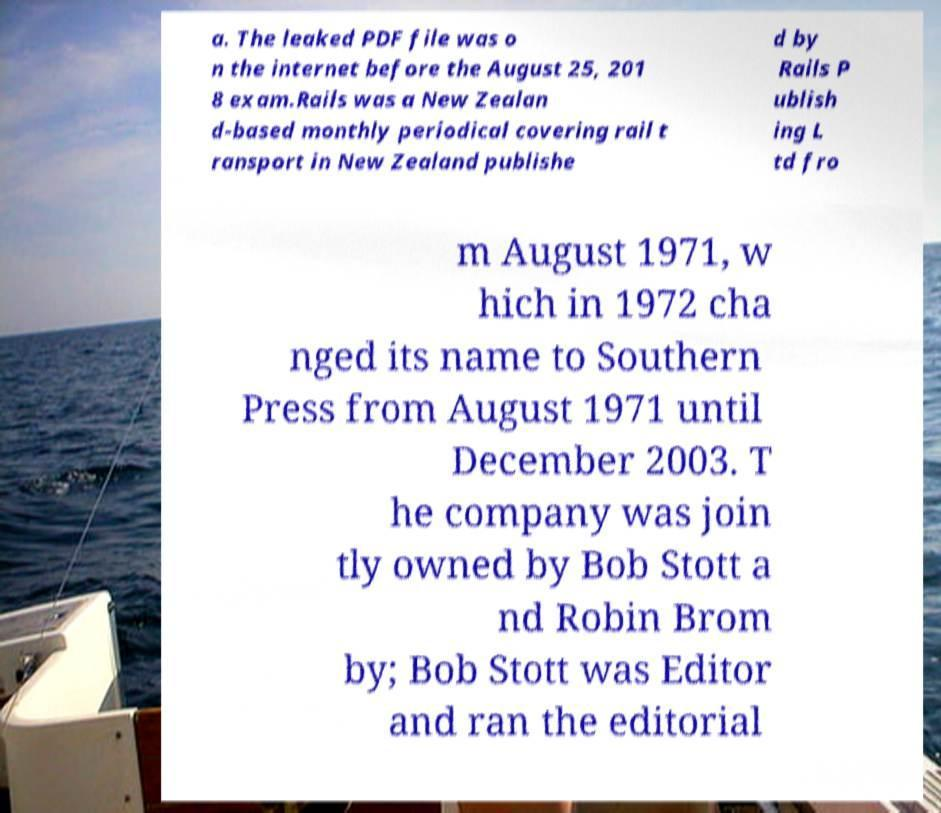Can you read and provide the text displayed in the image?This photo seems to have some interesting text. Can you extract and type it out for me? a. The leaked PDF file was o n the internet before the August 25, 201 8 exam.Rails was a New Zealan d-based monthly periodical covering rail t ransport in New Zealand publishe d by Rails P ublish ing L td fro m August 1971, w hich in 1972 cha nged its name to Southern Press from August 1971 until December 2003. T he company was join tly owned by Bob Stott a nd Robin Brom by; Bob Stott was Editor and ran the editorial 